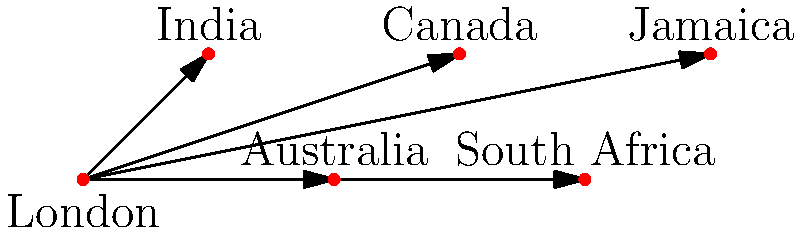In the context of the British Empire's linguistic influence, examine the network graph depicting the spread of the English language from London to various colonies. Which graph theory concept best describes London's role in this linguistic dissemination, and how might this relate to the socio-linguistic impact of the Empire on its territories? To answer this question, let us analyse the graph step-by-step:

1. Observe that London is connected directly to all other nodes (India, Australia, Canada, South Africa, and Jamaica).

2. In graph theory, a node connected to all other nodes in the graph is called a "central node" or, more specifically, a "star node".

3. The graph structure resembles a "star topology", where London acts as the central hub.

4. In the context of linguistic spread:
   a) London represents the source of the English language.
   b) The arrows indicate the direction of language dissemination.
   c) Each colony (represented by other nodes) received the English language directly from London.

5. This star topology in linguistic terms suggests:
   a) A centralized model of language spread.
   b) Direct linguistic influence from the imperial centre (London) to each colony.
   c) Potential for linguistic standardization across the empire, with London as the linguistic authority.

6. Socio-linguistically, this model implies:
   a) A hierarchical relationship between the imperial centre and its colonies.
   b) The potential for linguistic imperialism, where the language of the colonizer becomes dominant.
   c) The creation of a shared linguistic identity across diverse territories of the empire.

Therefore, the graph theory concept that best describes London's role is that of a "central node" in a "star topology". This reflects the centralized nature of the British Empire's linguistic influence, emanating from London to its far-flung colonies, and underscores the profound socio-linguistic impact of imperial rule on colonized territories.
Answer: Central node in a star topology 